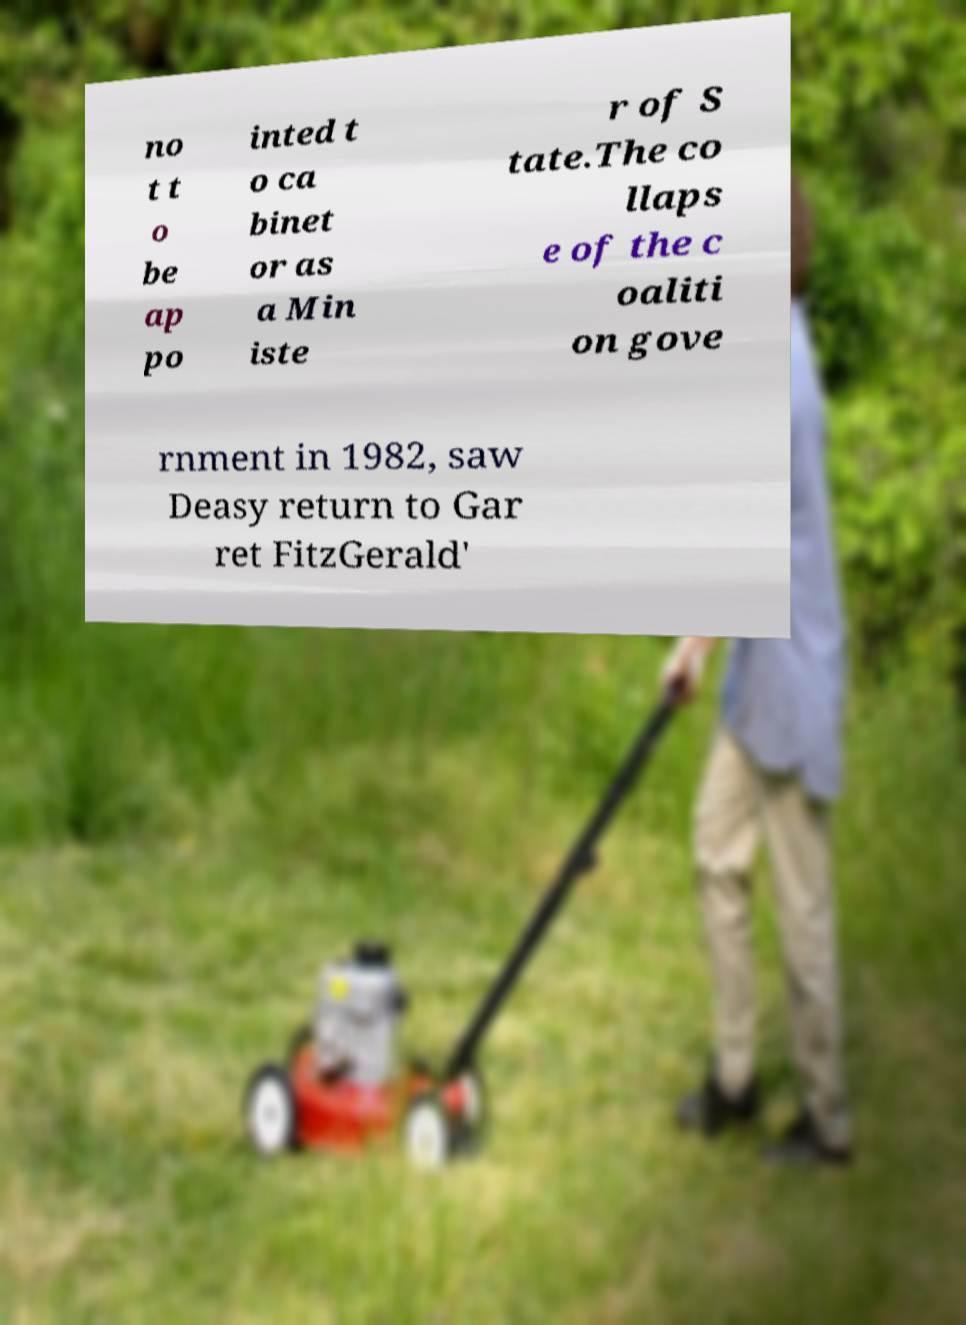Can you accurately transcribe the text from the provided image for me? no t t o be ap po inted t o ca binet or as a Min iste r of S tate.The co llaps e of the c oaliti on gove rnment in 1982, saw Deasy return to Gar ret FitzGerald' 